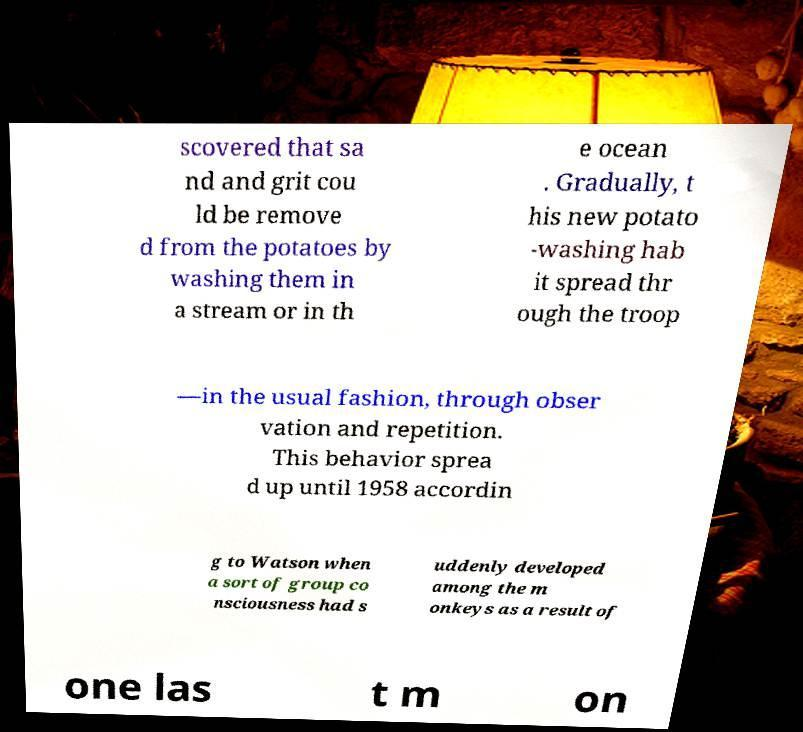Can you accurately transcribe the text from the provided image for me? scovered that sa nd and grit cou ld be remove d from the potatoes by washing them in a stream or in th e ocean . Gradually, t his new potato -washing hab it spread thr ough the troop —in the usual fashion, through obser vation and repetition. This behavior sprea d up until 1958 accordin g to Watson when a sort of group co nsciousness had s uddenly developed among the m onkeys as a result of one las t m on 